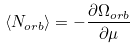Convert formula to latex. <formula><loc_0><loc_0><loc_500><loc_500>\langle N _ { o r b } \rangle = - \frac { \partial \Omega _ { o r b } } { \partial \mu }</formula> 